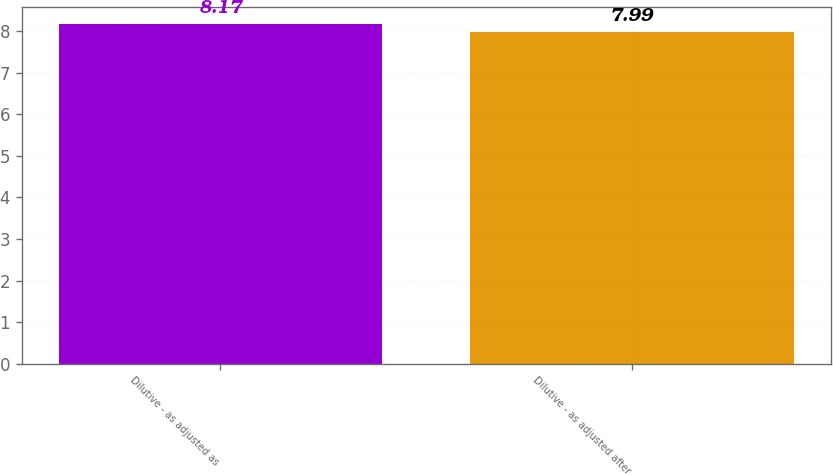Convert chart. <chart><loc_0><loc_0><loc_500><loc_500><bar_chart><fcel>Dilutive - as adjusted as<fcel>Dilutive - as adjusted after<nl><fcel>8.17<fcel>7.99<nl></chart> 